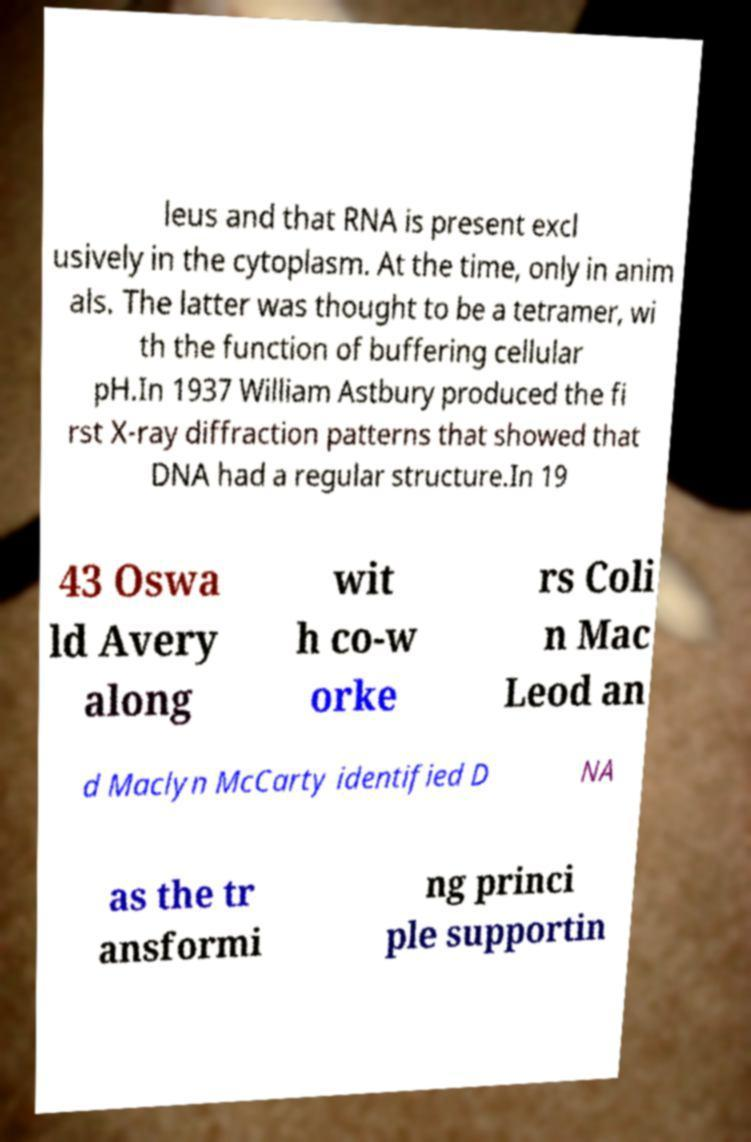Please identify and transcribe the text found in this image. leus and that RNA is present excl usively in the cytoplasm. At the time, only in anim als. The latter was thought to be a tetramer, wi th the function of buffering cellular pH.In 1937 William Astbury produced the fi rst X-ray diffraction patterns that showed that DNA had a regular structure.In 19 43 Oswa ld Avery along wit h co-w orke rs Coli n Mac Leod an d Maclyn McCarty identified D NA as the tr ansformi ng princi ple supportin 